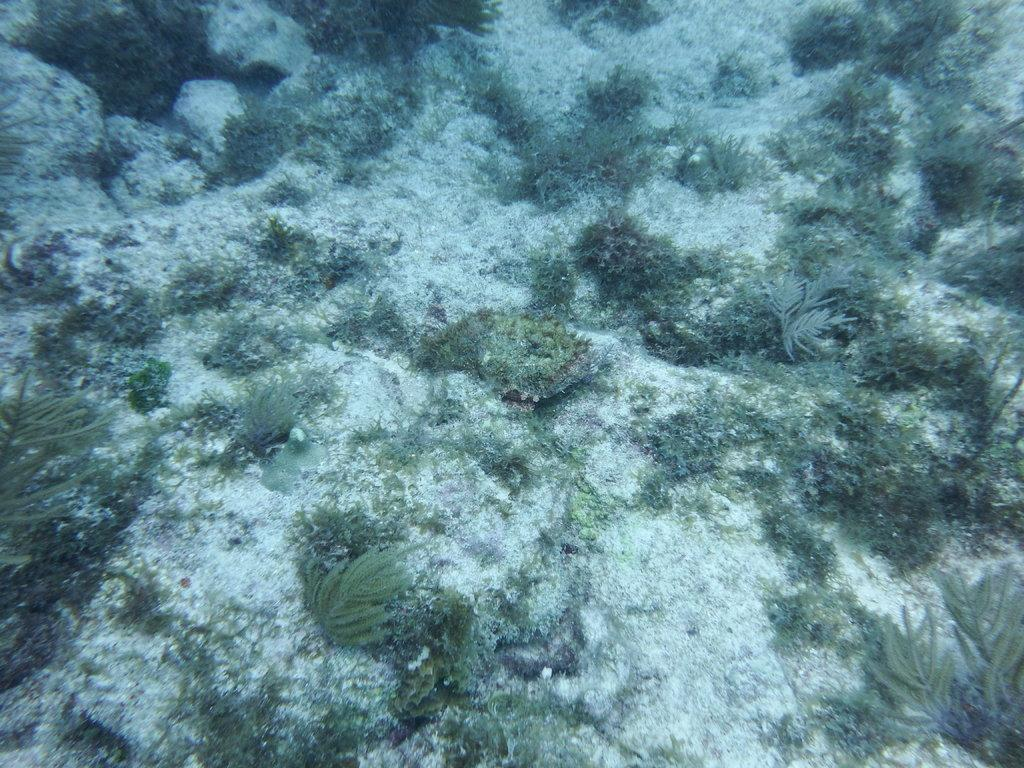What type of environment is depicted in the foreground of the image? The foreground of the image contains grass and plants. What is the condition of the grass and plants in the image? The grass and plants are underwater. What type of canvas is visible in the image? There is no canvas present in the image. What mineral is used to make the coat in the image? There is no coat present in the image. 